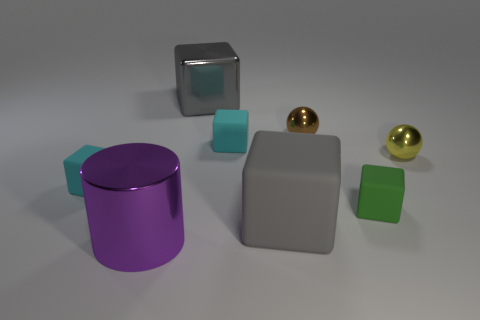Add 2 tiny yellow cylinders. How many objects exist? 10 Subtract all yellow spheres. How many spheres are left? 1 Subtract all cyan blocks. How many blocks are left? 3 Subtract all cylinders. How many objects are left? 7 Subtract all gray cylinders. How many brown spheres are left? 1 Subtract all tiny brown metal objects. Subtract all gray shiny objects. How many objects are left? 6 Add 2 tiny things. How many tiny things are left? 7 Add 7 brown metallic balls. How many brown metallic balls exist? 8 Subtract 0 cyan cylinders. How many objects are left? 8 Subtract 1 balls. How many balls are left? 1 